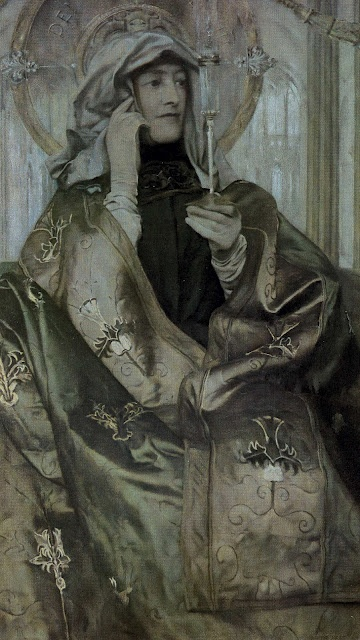Can you describe the woman's expression and what it might signify? The woman's expression appears contemplative and serene, with her eyes gently gazing towards the white flower she holds in her hand. This demeanor suggests a sense of introspection and peaceful meditation. Her calm and composed appearance, combined with the delicate handling of the flower, conveys a sense of reverence and tranquility, possibly indicating a moment of personal reflection or a spiritual experience. 